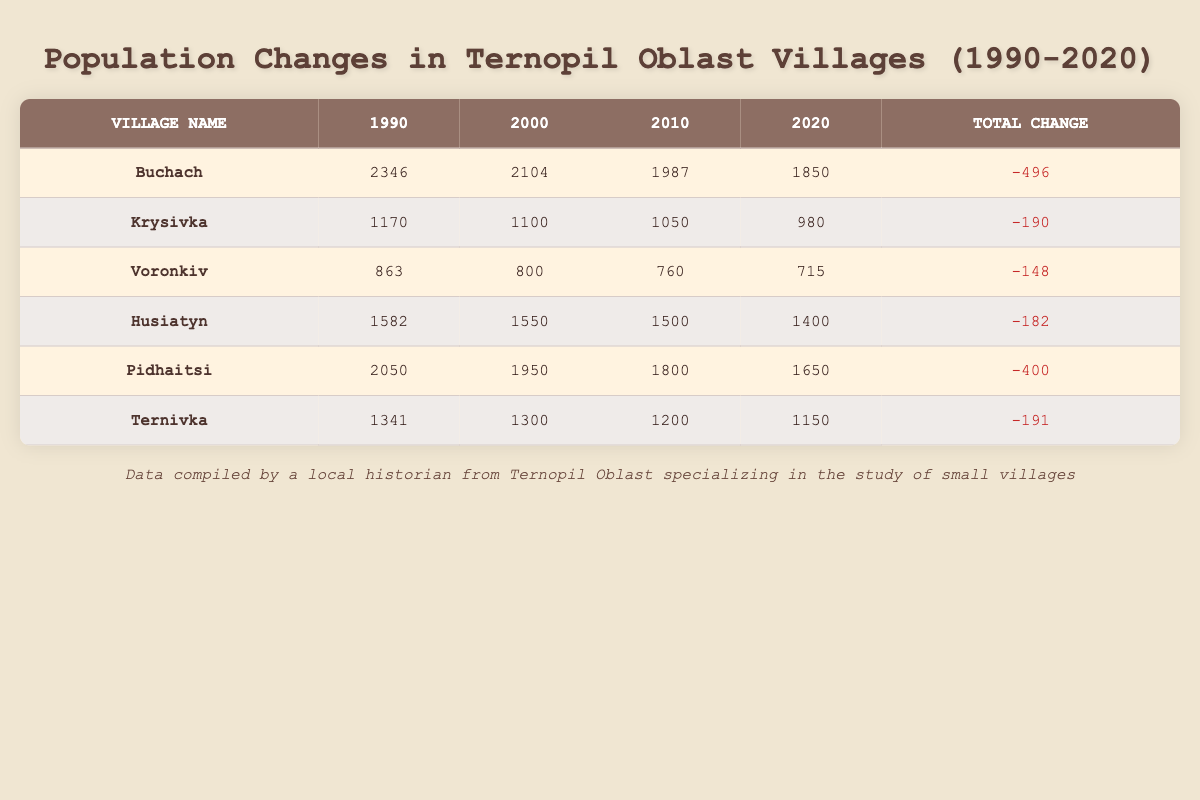What was the population of Buchach in 2020? The table shows the population of Buchach as 1850 in the year 2020.
Answer: 1850 Which village had the smallest population in 1990? By reviewing the first column for 1990, Voronkiv has the smallest population of 863.
Answer: Voronkiv What was the total population decrease in the village of Pidhaitsi from 1990 to 2020? The population in Pidhaitsi was 2050 in 1990 and dropped to 1650 by 2020. The decrease is calculated as 2050 - 1650 = 400.
Answer: 400 If we average the population in 2010 for all villages, what is the average? The populations for 2010 are: 1987, 1050, 760, 1500, 1800, 1200. Adding these gives a total of 8297. There are 6 villages, so the average is 8297 / 6 ≈ 1382.83.
Answer: Approximately 1383 Is it true that more than half of the villages had a population over 2000 in 1990? In 1990, the villages with populations over 2000 were Buchach (2346) and Pidhaitsi (2050). Since there are 6 villages total, only 2 had populations above 2000, which is not more than half.
Answer: No Which village experienced the largest decline in population from 1990 to 2020? The populations are: Buchach (2346 to 1850) with -496, Krysivka (1170 to 980) with -190, Voronkiv (863 to 715) with -148, Husiatyn (1582 to 1400) with -182, Pidhaitsi (2050 to 1650) with -400, and Ternivka (1341 to 1150) with -191. Buchach had the largest decline of 496.
Answer: Buchach What was the population of Ternivka in 2000? The table shows that Ternivka had a population of 1300 in the year 2000.
Answer: 1300 Did Krysivka's population decrease every decade from 1990 to 2020? The populations for Krysivka are: 1170 in 1990, 1100 in 2000, 1050 in 2010, and 980 in 2020. Each decade shows a decrease in population, confirming that it did decrease every decade from 1990 to 2020.
Answer: Yes 